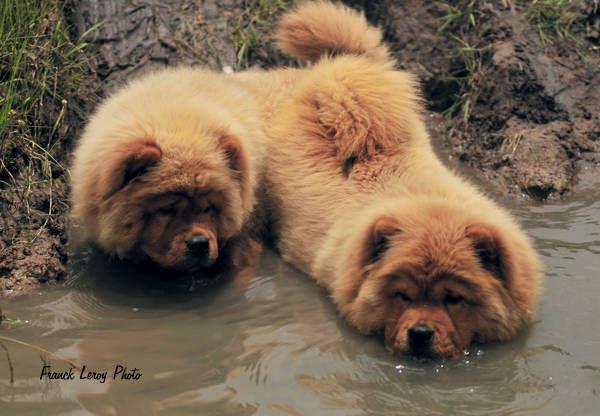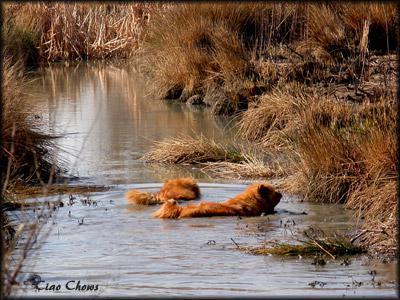The first image is the image on the left, the second image is the image on the right. For the images shown, is this caption "The left image contains exactly two dogs." true? Answer yes or no. Yes. The first image is the image on the left, the second image is the image on the right. Given the left and right images, does the statement "One dog in the image on the right is standing on a grassy area." hold true? Answer yes or no. No. 